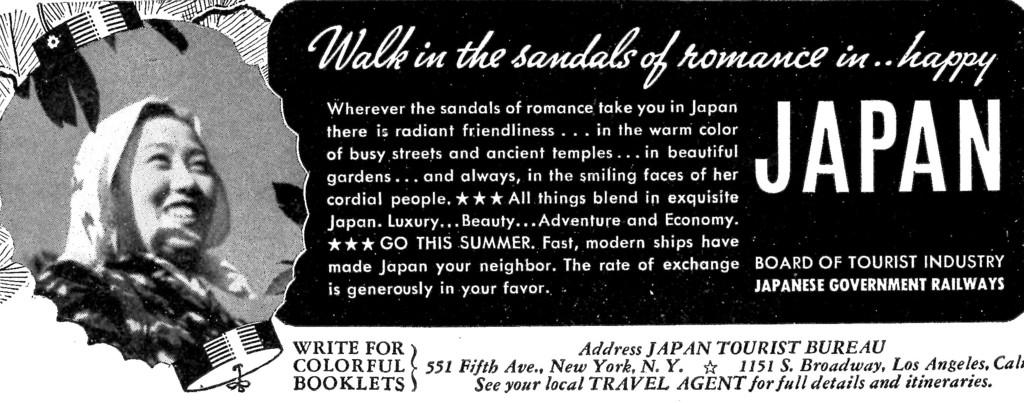What is the color scheme of the image? The image is black and white. What is the main subject of the image? There is a picture of a woman in the image. What else can be seen in the image besides the woman? There is some text beside the picture of the woman. What year does the plot of the image take place in? The image does not depict a plot or story, and there is no indication of a specific year. 